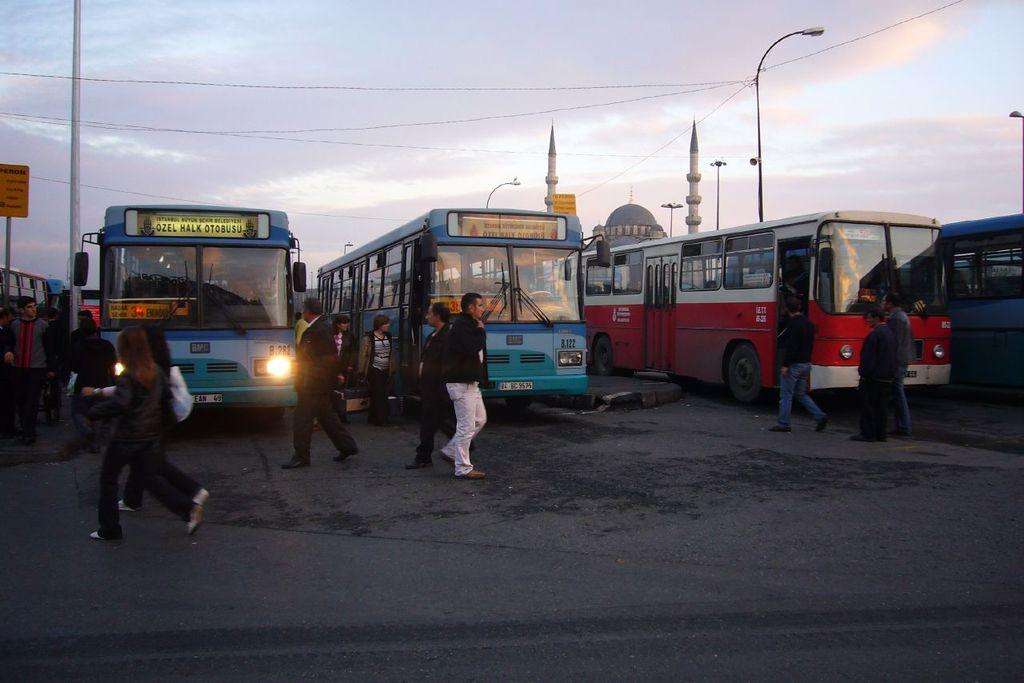Who or what can be seen in the image? There are people in the image. What type of vehicles are on the road in the image? There are buses on the road in the image. What structures are present in the image? There are light poles and buildings in the image. What are the boards used for in the image? The boards in the image are likely used for advertising or displaying information. What is visible in the background of the image? The sky with clouds is visible in the background of the image. Can you see a friend looking at a horse in the image? There is no friend or horse present in the image. 